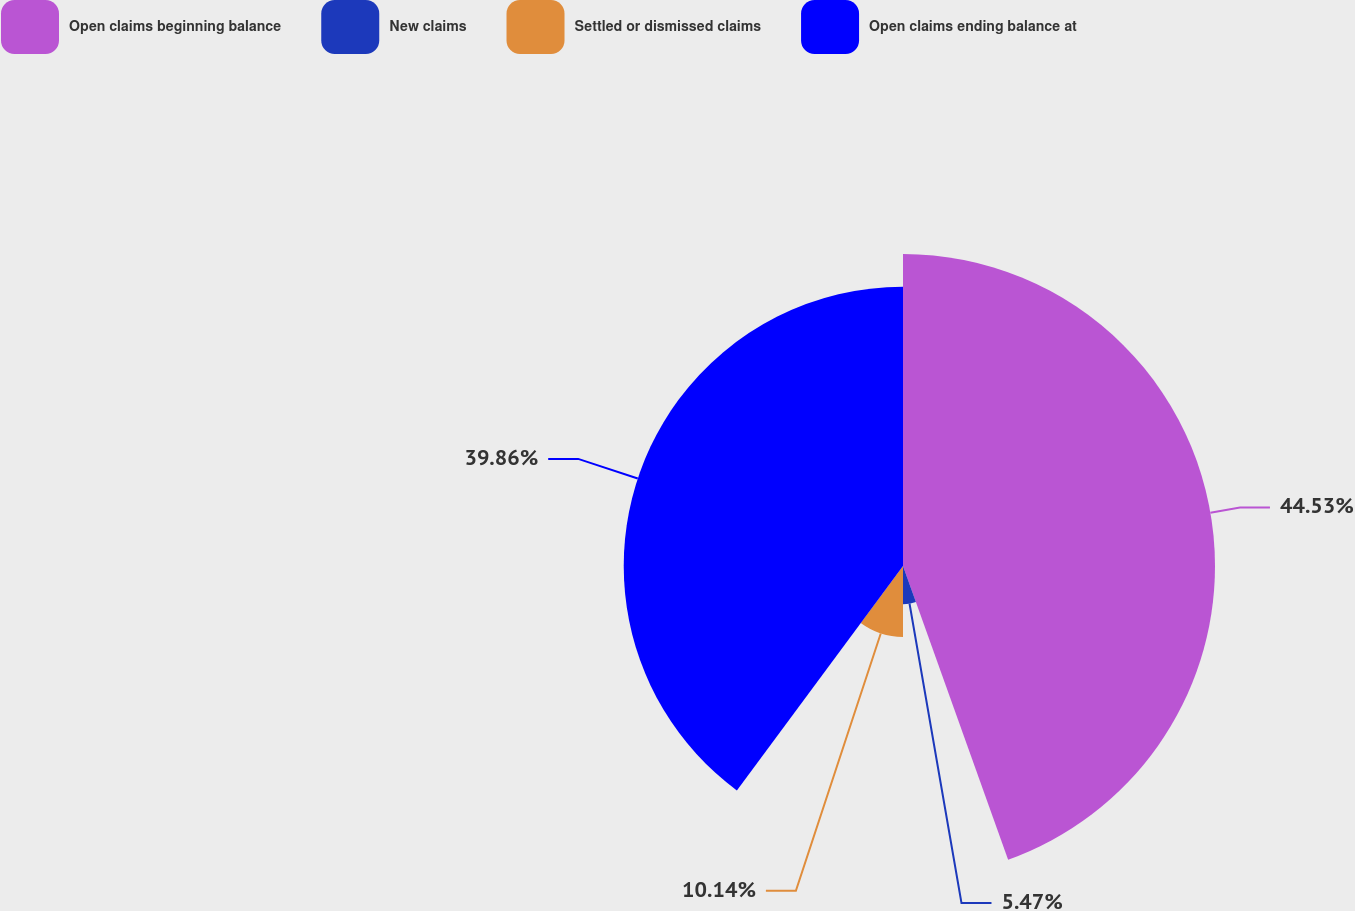<chart> <loc_0><loc_0><loc_500><loc_500><pie_chart><fcel>Open claims beginning balance<fcel>New claims<fcel>Settled or dismissed claims<fcel>Open claims ending balance at<nl><fcel>44.53%<fcel>5.47%<fcel>10.14%<fcel>39.86%<nl></chart> 